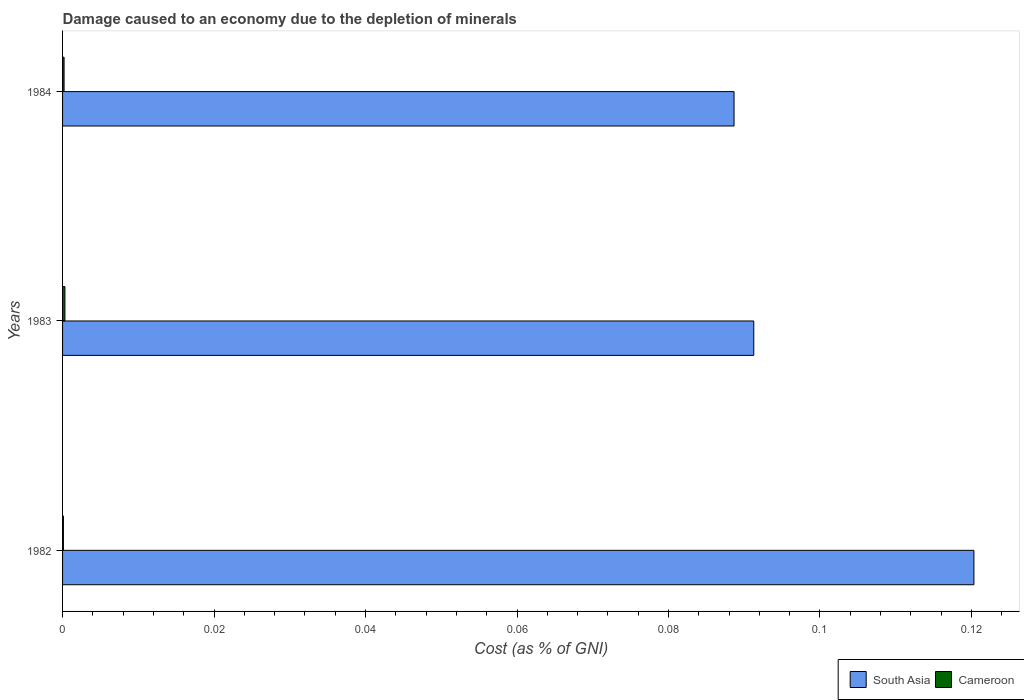What is the cost of damage caused due to the depletion of minerals in South Asia in 1983?
Offer a terse response. 0.09. Across all years, what is the maximum cost of damage caused due to the depletion of minerals in South Asia?
Keep it short and to the point. 0.12. Across all years, what is the minimum cost of damage caused due to the depletion of minerals in Cameroon?
Make the answer very short. 0. In which year was the cost of damage caused due to the depletion of minerals in Cameroon maximum?
Your answer should be very brief. 1983. What is the total cost of damage caused due to the depletion of minerals in South Asia in the graph?
Keep it short and to the point. 0.3. What is the difference between the cost of damage caused due to the depletion of minerals in Cameroon in 1983 and that in 1984?
Ensure brevity in your answer.  0. What is the difference between the cost of damage caused due to the depletion of minerals in Cameroon in 1982 and the cost of damage caused due to the depletion of minerals in South Asia in 1984?
Offer a very short reply. -0.09. What is the average cost of damage caused due to the depletion of minerals in South Asia per year?
Offer a terse response. 0.1. In the year 1983, what is the difference between the cost of damage caused due to the depletion of minerals in Cameroon and cost of damage caused due to the depletion of minerals in South Asia?
Offer a terse response. -0.09. In how many years, is the cost of damage caused due to the depletion of minerals in Cameroon greater than 0.092 %?
Ensure brevity in your answer.  0. What is the ratio of the cost of damage caused due to the depletion of minerals in Cameroon in 1982 to that in 1983?
Keep it short and to the point. 0.36. Is the cost of damage caused due to the depletion of minerals in South Asia in 1982 less than that in 1983?
Offer a very short reply. No. Is the difference between the cost of damage caused due to the depletion of minerals in Cameroon in 1982 and 1984 greater than the difference between the cost of damage caused due to the depletion of minerals in South Asia in 1982 and 1984?
Make the answer very short. No. What is the difference between the highest and the second highest cost of damage caused due to the depletion of minerals in South Asia?
Offer a very short reply. 0.03. What is the difference between the highest and the lowest cost of damage caused due to the depletion of minerals in Cameroon?
Provide a succinct answer. 0. Is the sum of the cost of damage caused due to the depletion of minerals in Cameroon in 1982 and 1983 greater than the maximum cost of damage caused due to the depletion of minerals in South Asia across all years?
Offer a very short reply. No. What does the 2nd bar from the top in 1983 represents?
Ensure brevity in your answer.  South Asia. What does the 1st bar from the bottom in 1983 represents?
Your response must be concise. South Asia. How many bars are there?
Provide a succinct answer. 6. Are all the bars in the graph horizontal?
Give a very brief answer. Yes. Are the values on the major ticks of X-axis written in scientific E-notation?
Provide a succinct answer. No. Does the graph contain any zero values?
Your response must be concise. No. Does the graph contain grids?
Your response must be concise. No. Where does the legend appear in the graph?
Keep it short and to the point. Bottom right. How many legend labels are there?
Ensure brevity in your answer.  2. What is the title of the graph?
Your answer should be compact. Damage caused to an economy due to the depletion of minerals. Does "Estonia" appear as one of the legend labels in the graph?
Your response must be concise. No. What is the label or title of the X-axis?
Give a very brief answer. Cost (as % of GNI). What is the Cost (as % of GNI) in South Asia in 1982?
Your answer should be very brief. 0.12. What is the Cost (as % of GNI) of Cameroon in 1982?
Your answer should be very brief. 0. What is the Cost (as % of GNI) of South Asia in 1983?
Make the answer very short. 0.09. What is the Cost (as % of GNI) in Cameroon in 1983?
Your answer should be very brief. 0. What is the Cost (as % of GNI) in South Asia in 1984?
Your answer should be very brief. 0.09. What is the Cost (as % of GNI) in Cameroon in 1984?
Provide a short and direct response. 0. Across all years, what is the maximum Cost (as % of GNI) of South Asia?
Make the answer very short. 0.12. Across all years, what is the maximum Cost (as % of GNI) in Cameroon?
Your answer should be compact. 0. Across all years, what is the minimum Cost (as % of GNI) of South Asia?
Keep it short and to the point. 0.09. Across all years, what is the minimum Cost (as % of GNI) of Cameroon?
Offer a terse response. 0. What is the total Cost (as % of GNI) of South Asia in the graph?
Your answer should be compact. 0.3. What is the total Cost (as % of GNI) of Cameroon in the graph?
Ensure brevity in your answer.  0. What is the difference between the Cost (as % of GNI) in South Asia in 1982 and that in 1983?
Offer a terse response. 0.03. What is the difference between the Cost (as % of GNI) in Cameroon in 1982 and that in 1983?
Offer a very short reply. -0. What is the difference between the Cost (as % of GNI) in South Asia in 1982 and that in 1984?
Offer a terse response. 0.03. What is the difference between the Cost (as % of GNI) in Cameroon in 1982 and that in 1984?
Offer a very short reply. -0. What is the difference between the Cost (as % of GNI) of South Asia in 1983 and that in 1984?
Your answer should be very brief. 0. What is the difference between the Cost (as % of GNI) of South Asia in 1982 and the Cost (as % of GNI) of Cameroon in 1983?
Offer a very short reply. 0.12. What is the difference between the Cost (as % of GNI) of South Asia in 1982 and the Cost (as % of GNI) of Cameroon in 1984?
Your answer should be very brief. 0.12. What is the difference between the Cost (as % of GNI) of South Asia in 1983 and the Cost (as % of GNI) of Cameroon in 1984?
Provide a succinct answer. 0.09. What is the average Cost (as % of GNI) of South Asia per year?
Your answer should be very brief. 0.1. What is the average Cost (as % of GNI) of Cameroon per year?
Your response must be concise. 0. In the year 1982, what is the difference between the Cost (as % of GNI) in South Asia and Cost (as % of GNI) in Cameroon?
Give a very brief answer. 0.12. In the year 1983, what is the difference between the Cost (as % of GNI) in South Asia and Cost (as % of GNI) in Cameroon?
Your answer should be compact. 0.09. In the year 1984, what is the difference between the Cost (as % of GNI) of South Asia and Cost (as % of GNI) of Cameroon?
Ensure brevity in your answer.  0.09. What is the ratio of the Cost (as % of GNI) in South Asia in 1982 to that in 1983?
Your response must be concise. 1.32. What is the ratio of the Cost (as % of GNI) in Cameroon in 1982 to that in 1983?
Make the answer very short. 0.36. What is the ratio of the Cost (as % of GNI) in South Asia in 1982 to that in 1984?
Offer a terse response. 1.36. What is the ratio of the Cost (as % of GNI) in Cameroon in 1982 to that in 1984?
Offer a very short reply. 0.56. What is the ratio of the Cost (as % of GNI) in South Asia in 1983 to that in 1984?
Provide a short and direct response. 1.03. What is the ratio of the Cost (as % of GNI) of Cameroon in 1983 to that in 1984?
Provide a succinct answer. 1.55. What is the difference between the highest and the second highest Cost (as % of GNI) of South Asia?
Keep it short and to the point. 0.03. What is the difference between the highest and the second highest Cost (as % of GNI) of Cameroon?
Your response must be concise. 0. What is the difference between the highest and the lowest Cost (as % of GNI) in South Asia?
Your answer should be compact. 0.03. What is the difference between the highest and the lowest Cost (as % of GNI) of Cameroon?
Offer a terse response. 0. 